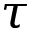Convert formula to latex. <formula><loc_0><loc_0><loc_500><loc_500>\tau</formula> 